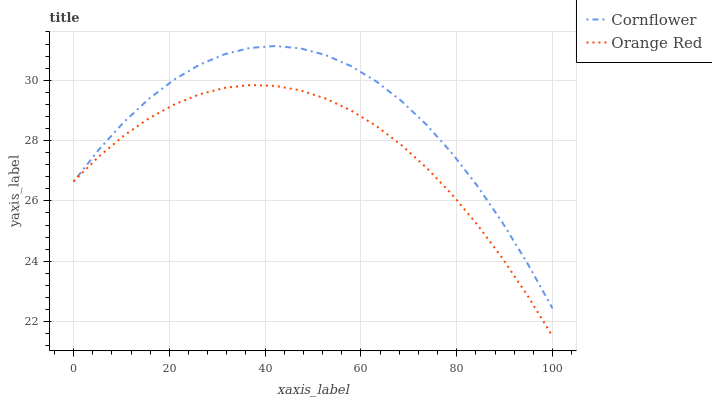Does Orange Red have the minimum area under the curve?
Answer yes or no. Yes. Does Cornflower have the maximum area under the curve?
Answer yes or no. Yes. Does Orange Red have the maximum area under the curve?
Answer yes or no. No. Is Orange Red the smoothest?
Answer yes or no. Yes. Is Cornflower the roughest?
Answer yes or no. Yes. Is Orange Red the roughest?
Answer yes or no. No. Does Orange Red have the lowest value?
Answer yes or no. Yes. Does Cornflower have the highest value?
Answer yes or no. Yes. Does Orange Red have the highest value?
Answer yes or no. No. Does Orange Red intersect Cornflower?
Answer yes or no. Yes. Is Orange Red less than Cornflower?
Answer yes or no. No. Is Orange Red greater than Cornflower?
Answer yes or no. No. 